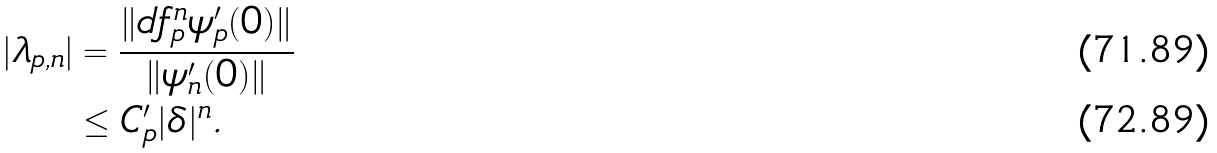<formula> <loc_0><loc_0><loc_500><loc_500>| \lambda _ { p , n } | & = \frac { \| d f ^ { n } _ { p } \psi _ { p } ^ { \prime } ( 0 ) \| } { \| \psi _ { n } ^ { \prime } ( 0 ) \| } \\ & \leq C ^ { \prime } _ { p } | \delta | ^ { n } .</formula> 